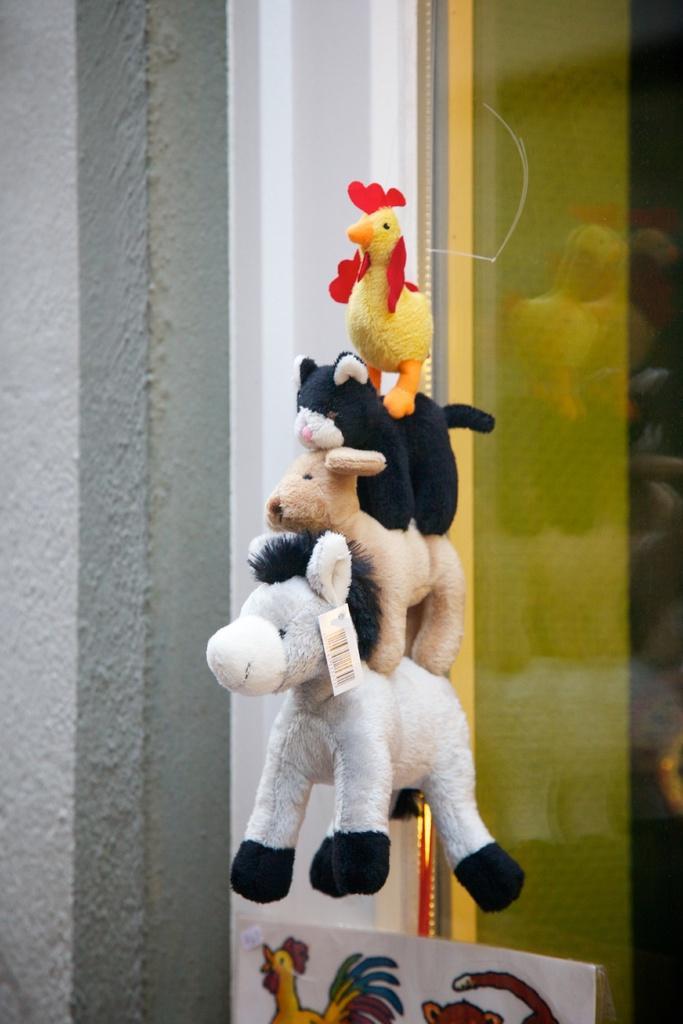How would you summarize this image in a sentence or two? In this image in the foreground we can see there are toys one after the others. 